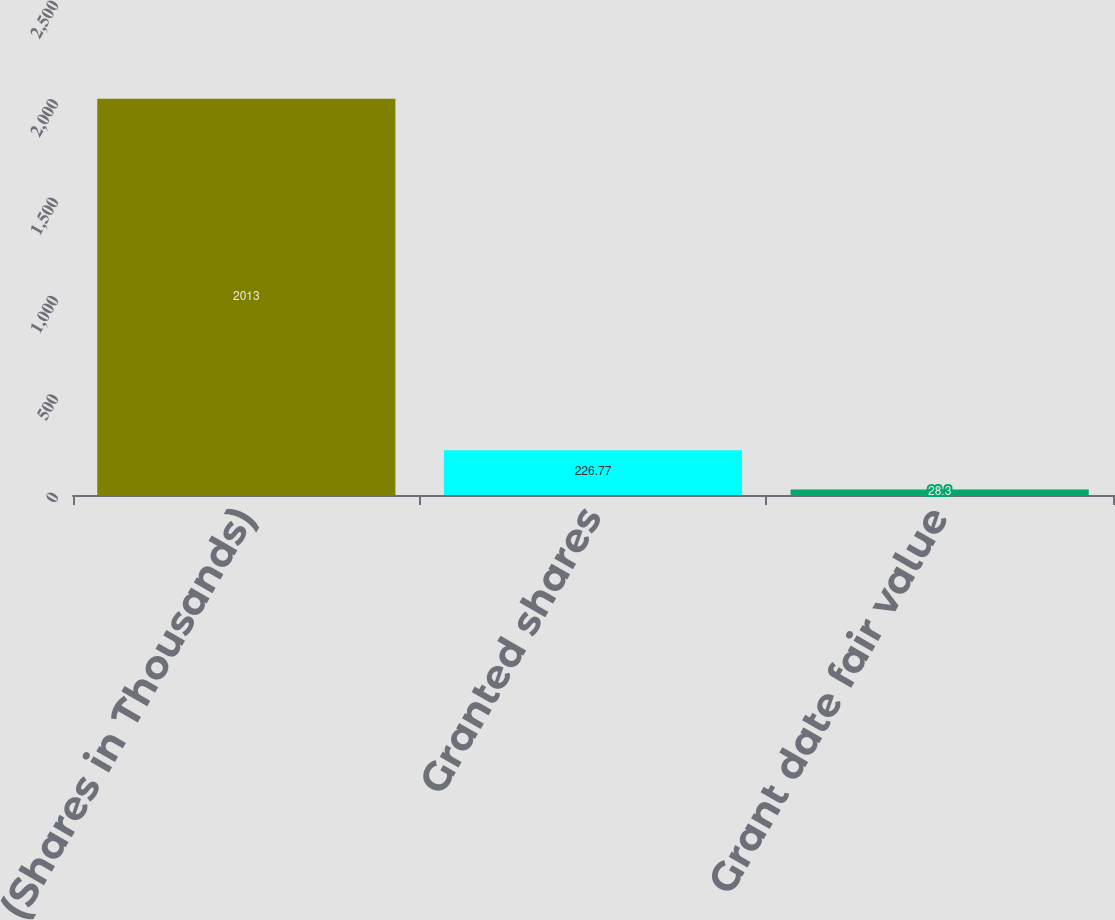Convert chart. <chart><loc_0><loc_0><loc_500><loc_500><bar_chart><fcel>(Shares in Thousands)<fcel>Granted shares<fcel>Grant date fair value<nl><fcel>2013<fcel>226.77<fcel>28.3<nl></chart> 